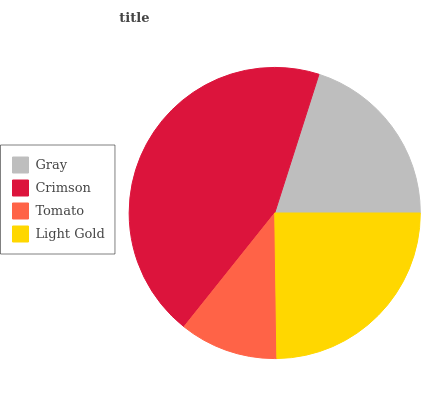Is Tomato the minimum?
Answer yes or no. Yes. Is Crimson the maximum?
Answer yes or no. Yes. Is Crimson the minimum?
Answer yes or no. No. Is Tomato the maximum?
Answer yes or no. No. Is Crimson greater than Tomato?
Answer yes or no. Yes. Is Tomato less than Crimson?
Answer yes or no. Yes. Is Tomato greater than Crimson?
Answer yes or no. No. Is Crimson less than Tomato?
Answer yes or no. No. Is Light Gold the high median?
Answer yes or no. Yes. Is Gray the low median?
Answer yes or no. Yes. Is Crimson the high median?
Answer yes or no. No. Is Crimson the low median?
Answer yes or no. No. 